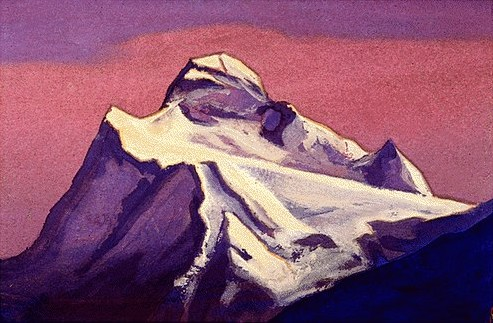What artistic techniques make this painting so striking? The painting's striking quality arises from several key artistic techniques. Foremost is the use of impressionistic brushwork, which lends a sense of movement and spontaneity. The interplay of light and shadow is meticulously handled, with blue shadows giving the mountain a three-dimensional texture. The sky's vibrant colors contrast sharply with the mountain, yet harmonize to create a balanced composition. Additionally, the color palette evokes a specific time of day, perhaps sunrise or sunset, imbuing the scene with emotive depth. How would you describe the atmosphere of this place? The atmosphere of this painting is charged with a serene and almost otherworldly quality. The vibrant yet soft sky contrasts with the stark, imposing mountain, creating a balanced yet dynamic composition. It's a place where one can almost feel the cool mountain air, sense the tranquility of dusk or dawn, and experience a profound sense of peace amidst nature's grandeur. The painting encourages a contemplative mood, inviting viewers to ponder the vastness and beauty of the natural world. Is there any symbolic meaning that could be inferred? Symbolically, the mountain could represent ultimate strength, endurance, and majesty, standing tall through the passage of time. The contrasting colors of the sky, transitioning from pink to purple, might symbolize the fleeting nature of time, change, and the beauty of transitory moments. The ethereal lighting could signify enlightenment or revelation, as if the mountain is basking in a divine glow. Together, these elements suggest a harmony between the eternal and the ephemeral, a core theme of many impressionistic works. Imagine a legend or folklore associated with this mountain. In ancient folklore, the mountain is said to be the abode of a celestial guardian, a giant eagle with wings that shimmer with the colors of the sunset. According to legend, long ago, the eagle descended from the heavens to protect the valley below from malevolent spirits that thrived in darkness. Each evening, as the sky blazes with hues of pink and purple, it is believed that the eagle spreads its wings to shield the valley, casting a protective shadow over the land. The villagers tell tales of how the angelic guardian bestows wisdom upon those who climb the mountain with pure hearts and clear intentions, revealing truths about their past and guiding their future. On particularly magical nights, it is said that the guardian's cry echoes through the mountains, a call to the brave and the wise to embark on their journey of transformation. 